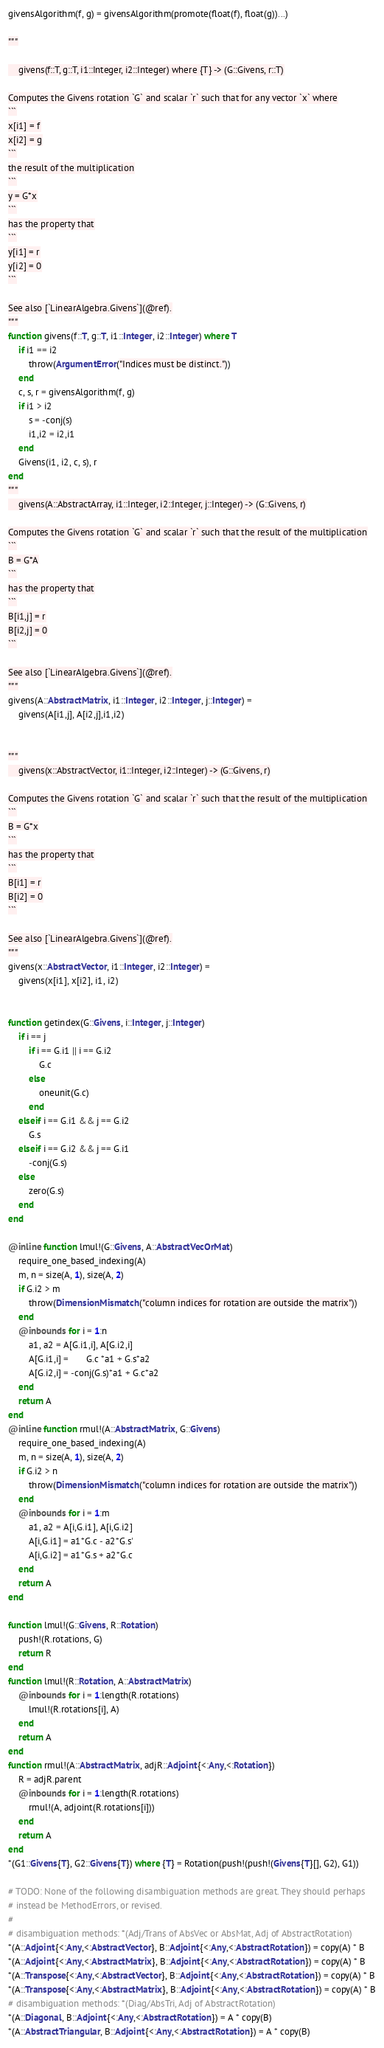<code> <loc_0><loc_0><loc_500><loc_500><_Julia_>givensAlgorithm(f, g) = givensAlgorithm(promote(float(f), float(g))...)

"""

    givens(f::T, g::T, i1::Integer, i2::Integer) where {T} -> (G::Givens, r::T)

Computes the Givens rotation `G` and scalar `r` such that for any vector `x` where
```
x[i1] = f
x[i2] = g
```
the result of the multiplication
```
y = G*x
```
has the property that
```
y[i1] = r
y[i2] = 0
```

See also [`LinearAlgebra.Givens`](@ref).
"""
function givens(f::T, g::T, i1::Integer, i2::Integer) where T
    if i1 == i2
        throw(ArgumentError("Indices must be distinct."))
    end
    c, s, r = givensAlgorithm(f, g)
    if i1 > i2
        s = -conj(s)
        i1,i2 = i2,i1
    end
    Givens(i1, i2, c, s), r
end
"""
    givens(A::AbstractArray, i1::Integer, i2::Integer, j::Integer) -> (G::Givens, r)

Computes the Givens rotation `G` and scalar `r` such that the result of the multiplication
```
B = G*A
```
has the property that
```
B[i1,j] = r
B[i2,j] = 0
```

See also [`LinearAlgebra.Givens`](@ref).
"""
givens(A::AbstractMatrix, i1::Integer, i2::Integer, j::Integer) =
    givens(A[i1,j], A[i2,j],i1,i2)


"""
    givens(x::AbstractVector, i1::Integer, i2::Integer) -> (G::Givens, r)

Computes the Givens rotation `G` and scalar `r` such that the result of the multiplication
```
B = G*x
```
has the property that
```
B[i1] = r
B[i2] = 0
```

See also [`LinearAlgebra.Givens`](@ref).
"""
givens(x::AbstractVector, i1::Integer, i2::Integer) =
    givens(x[i1], x[i2], i1, i2)


function getindex(G::Givens, i::Integer, j::Integer)
    if i == j
        if i == G.i1 || i == G.i2
            G.c
        else
            oneunit(G.c)
        end
    elseif i == G.i1 && j == G.i2
        G.s
    elseif i == G.i2 && j == G.i1
        -conj(G.s)
    else
        zero(G.s)
    end
end

@inline function lmul!(G::Givens, A::AbstractVecOrMat)
    require_one_based_indexing(A)
    m, n = size(A, 1), size(A, 2)
    if G.i2 > m
        throw(DimensionMismatch("column indices for rotation are outside the matrix"))
    end
    @inbounds for i = 1:n
        a1, a2 = A[G.i1,i], A[G.i2,i]
        A[G.i1,i] =       G.c *a1 + G.s*a2
        A[G.i2,i] = -conj(G.s)*a1 + G.c*a2
    end
    return A
end
@inline function rmul!(A::AbstractMatrix, G::Givens)
    require_one_based_indexing(A)
    m, n = size(A, 1), size(A, 2)
    if G.i2 > n
        throw(DimensionMismatch("column indices for rotation are outside the matrix"))
    end
    @inbounds for i = 1:m
        a1, a2 = A[i,G.i1], A[i,G.i2]
        A[i,G.i1] = a1*G.c - a2*G.s'
        A[i,G.i2] = a1*G.s + a2*G.c
    end
    return A
end

function lmul!(G::Givens, R::Rotation)
    push!(R.rotations, G)
    return R
end
function lmul!(R::Rotation, A::AbstractMatrix)
    @inbounds for i = 1:length(R.rotations)
        lmul!(R.rotations[i], A)
    end
    return A
end
function rmul!(A::AbstractMatrix, adjR::Adjoint{<:Any,<:Rotation})
    R = adjR.parent
    @inbounds for i = 1:length(R.rotations)
        rmul!(A, adjoint(R.rotations[i]))
    end
    return A
end
*(G1::Givens{T}, G2::Givens{T}) where {T} = Rotation(push!(push!(Givens{T}[], G2), G1))

# TODO: None of the following disambiguation methods are great. They should perhaps
# instead be MethodErrors, or revised.
#
# disambiguation methods: *(Adj/Trans of AbsVec or AbsMat, Adj of AbstractRotation)
*(A::Adjoint{<:Any,<:AbstractVector}, B::Adjoint{<:Any,<:AbstractRotation}) = copy(A) * B
*(A::Adjoint{<:Any,<:AbstractMatrix}, B::Adjoint{<:Any,<:AbstractRotation}) = copy(A) * B
*(A::Transpose{<:Any,<:AbstractVector}, B::Adjoint{<:Any,<:AbstractRotation}) = copy(A) * B
*(A::Transpose{<:Any,<:AbstractMatrix}, B::Adjoint{<:Any,<:AbstractRotation}) = copy(A) * B
# disambiguation methods: *(Diag/AbsTri, Adj of AbstractRotation)
*(A::Diagonal, B::Adjoint{<:Any,<:AbstractRotation}) = A * copy(B)
*(A::AbstractTriangular, B::Adjoint{<:Any,<:AbstractRotation}) = A * copy(B)
</code> 